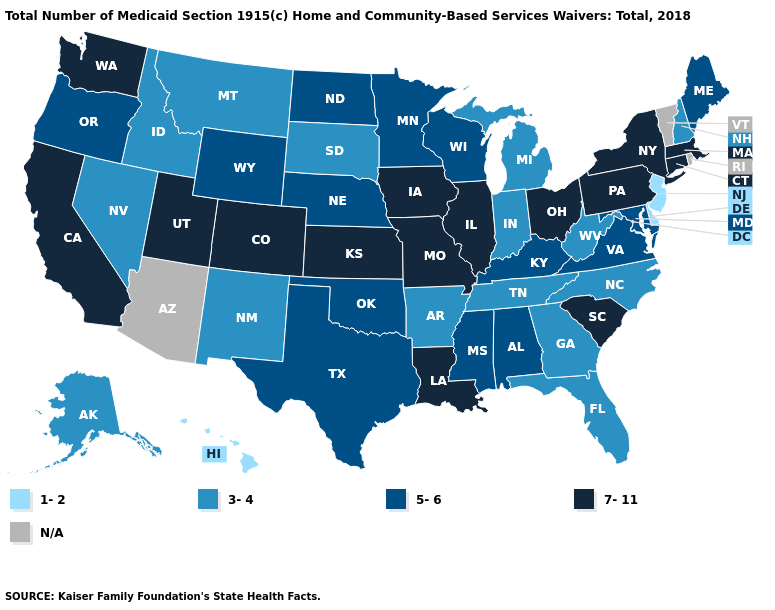Does Oklahoma have the highest value in the USA?
Concise answer only. No. Which states have the lowest value in the MidWest?
Concise answer only. Indiana, Michigan, South Dakota. What is the value of Massachusetts?
Give a very brief answer. 7-11. Name the states that have a value in the range 3-4?
Be succinct. Alaska, Arkansas, Florida, Georgia, Idaho, Indiana, Michigan, Montana, Nevada, New Hampshire, New Mexico, North Carolina, South Dakota, Tennessee, West Virginia. Does the map have missing data?
Concise answer only. Yes. What is the highest value in the Northeast ?
Be succinct. 7-11. Name the states that have a value in the range 5-6?
Give a very brief answer. Alabama, Kentucky, Maine, Maryland, Minnesota, Mississippi, Nebraska, North Dakota, Oklahoma, Oregon, Texas, Virginia, Wisconsin, Wyoming. Name the states that have a value in the range 7-11?
Be succinct. California, Colorado, Connecticut, Illinois, Iowa, Kansas, Louisiana, Massachusetts, Missouri, New York, Ohio, Pennsylvania, South Carolina, Utah, Washington. Name the states that have a value in the range 3-4?
Answer briefly. Alaska, Arkansas, Florida, Georgia, Idaho, Indiana, Michigan, Montana, Nevada, New Hampshire, New Mexico, North Carolina, South Dakota, Tennessee, West Virginia. Name the states that have a value in the range N/A?
Quick response, please. Arizona, Rhode Island, Vermont. Does Tennessee have the lowest value in the South?
Be succinct. No. What is the value of South Carolina?
Keep it brief. 7-11. What is the value of Florida?
Quick response, please. 3-4. Name the states that have a value in the range 3-4?
Answer briefly. Alaska, Arkansas, Florida, Georgia, Idaho, Indiana, Michigan, Montana, Nevada, New Hampshire, New Mexico, North Carolina, South Dakota, Tennessee, West Virginia. 